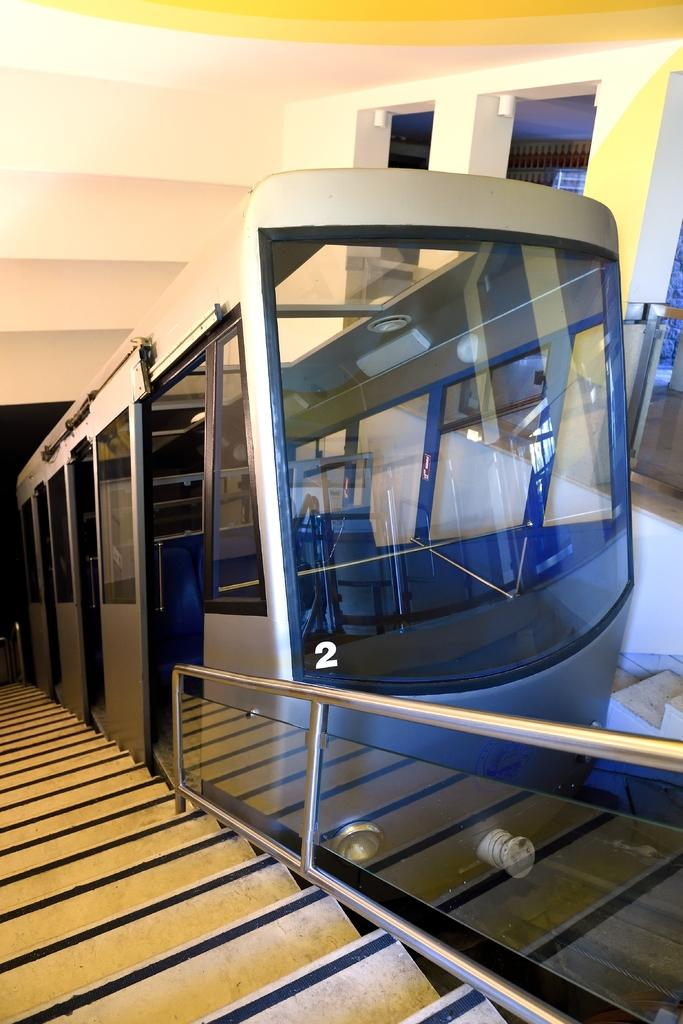What is the main subject of the image? The main subject of the image is a train. What other objects or structures can be seen in the image? There are stairs and railing visible in the image. What is the color of the roof in the image? The roof in the image is white-colored. Can you see a veil being used by the police in the image? There is no veil or police present in the image; it features a train, stairs, railing, and a white-colored roof. 